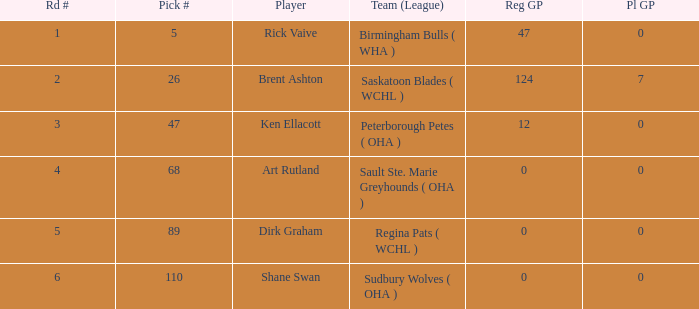During the first round, how many regular gp were recorded for rick vaive? None. 